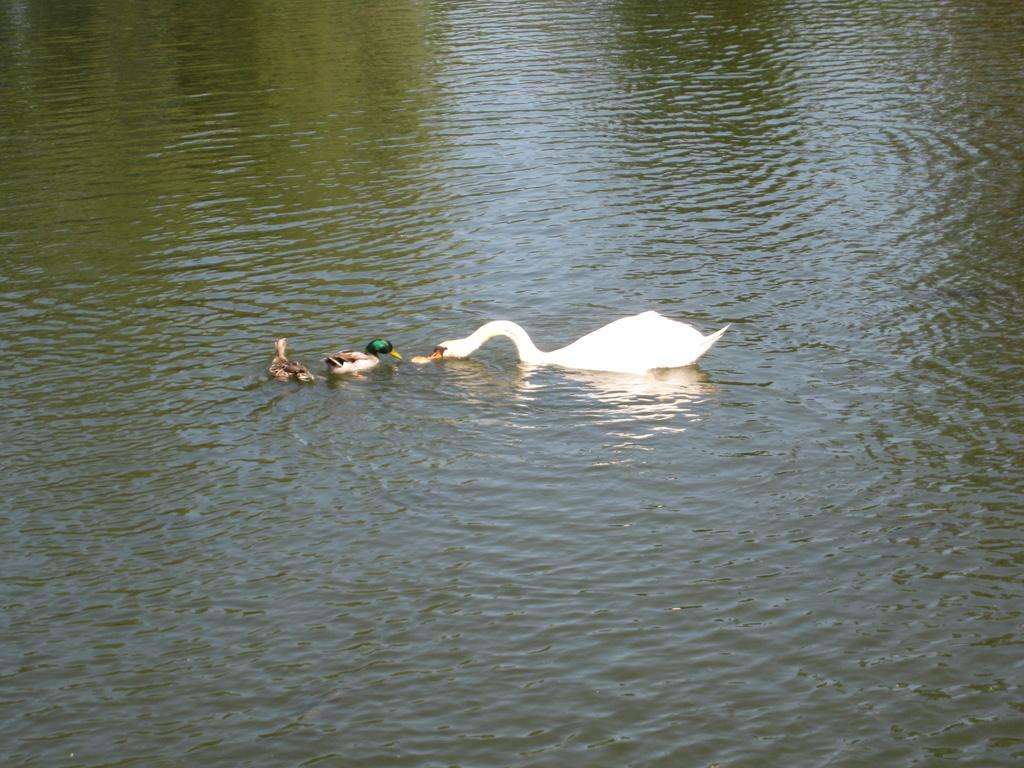What animals can be seen in the water in the foreground of the image? There are ducks in the water in the foreground of the image. What is the primary setting of the image? The primary setting of the image is the water where the ducks are located. Can you describe the position of the ducks in the image? The ducks are in the water in the foreground of the image. What type of stitch is used to sew the ducks' beaks in the image? There are no ducks with sewn beaks in the image, and therefore no stitch can be observed. 